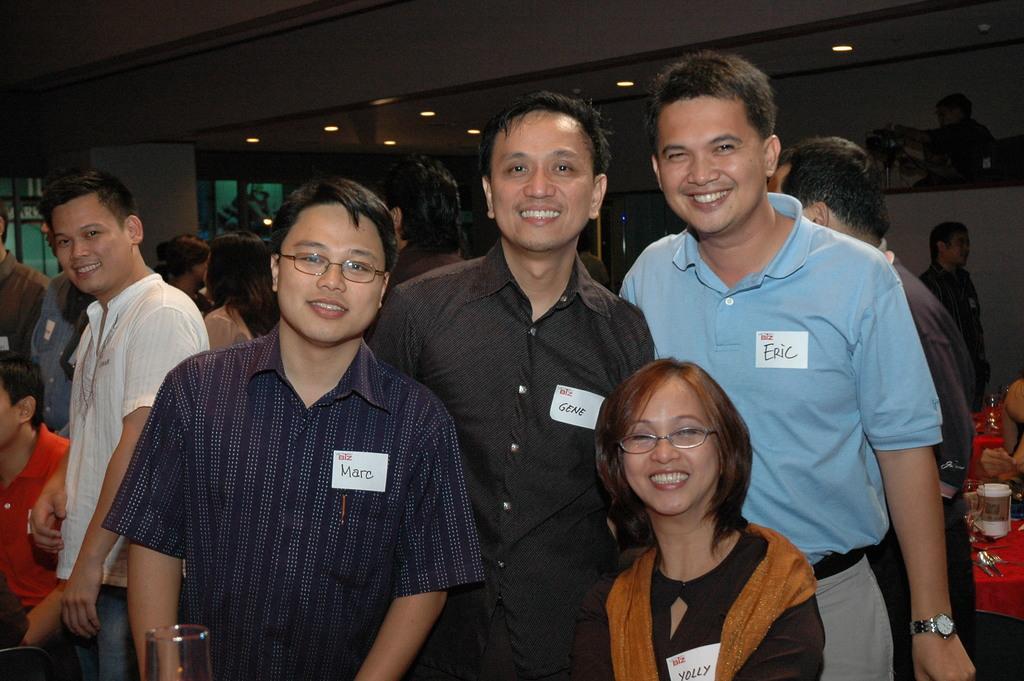Please provide a concise description of this image. In this picture we can see a group of people. At the bottom of the image, there is a glass. On the right side of the image, it looks like a table. On the table, there are some objects and a cup. Behind the people, there is a wall. At the top of the image, there are ceiling lights. 